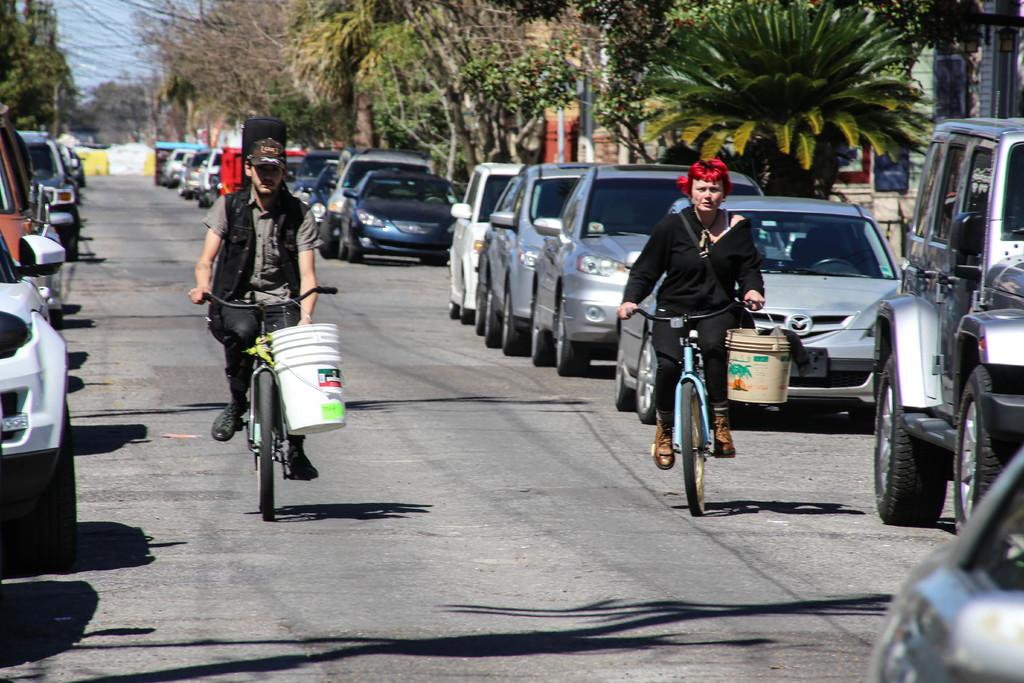What are the two people in the image doing? The two people in the image are riding bicycles on the road. What else can be seen on the road in the image? Cars are visible in the image. What structures are present in the background of the image? There are buildings in the image. What type of vegetation is present in the image? There are trees in the image. What type of bone is visible in the image? There is no bone present in the image. What message of hope can be seen in the image? There is no message of hope depicted in the image. 